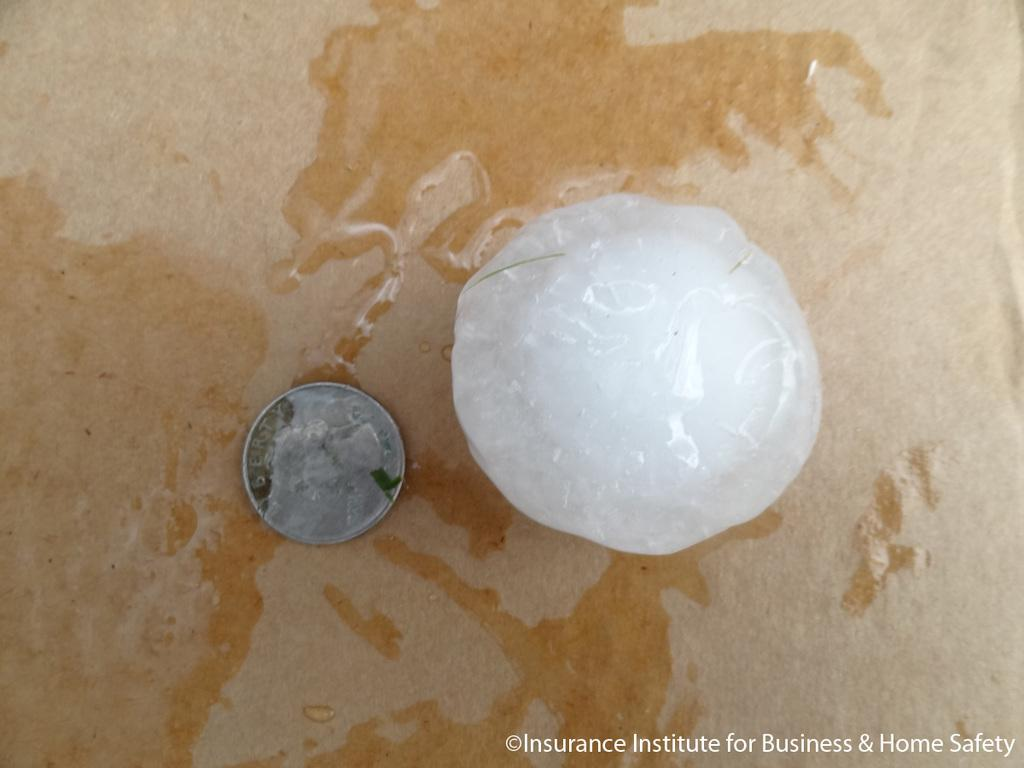<image>
Relay a brief, clear account of the picture shown. A quarter next to a small ball of ice on an advertisement from the Insurance Institute for Business & Home Safety. 